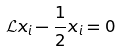<formula> <loc_0><loc_0><loc_500><loc_500>\mathcal { L } x _ { i } - \frac { 1 } { 2 } x _ { i } = 0</formula> 